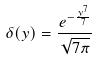<formula> <loc_0><loc_0><loc_500><loc_500>\delta ( y ) = \frac { e ^ { - \frac { y ^ { 7 } } { 7 } } } { \sqrt { 7 \pi } }</formula> 